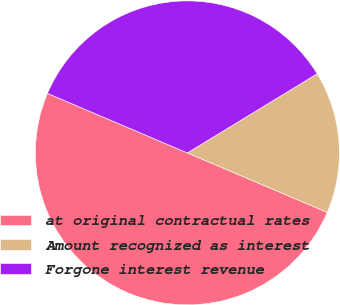Convert chart. <chart><loc_0><loc_0><loc_500><loc_500><pie_chart><fcel>at original contractual rates<fcel>Amount recognized as interest<fcel>Forgone interest revenue<nl><fcel>50.0%<fcel>15.12%<fcel>34.88%<nl></chart> 